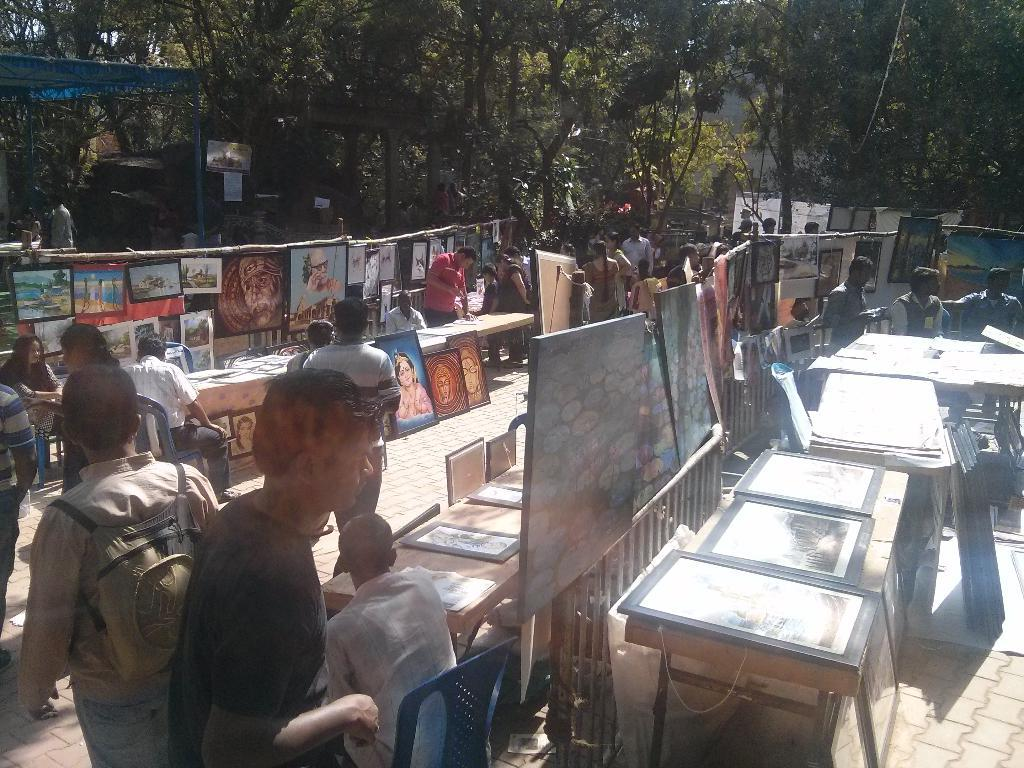What are the people in the image doing? The people in the image are both sitting and standing. What can be seen hanging on the walls in the image? Paintings are present in the image. What is located on the left side of the image? There is a tent on the left side of the image. What type of natural elements can be seen at the top of the image? Trees are visible at the top of the image. What time is displayed on the clock in the image? There is no clock present in the image. How many matches are being played in the image? There is no indication of a match or any sports activity in the image. 